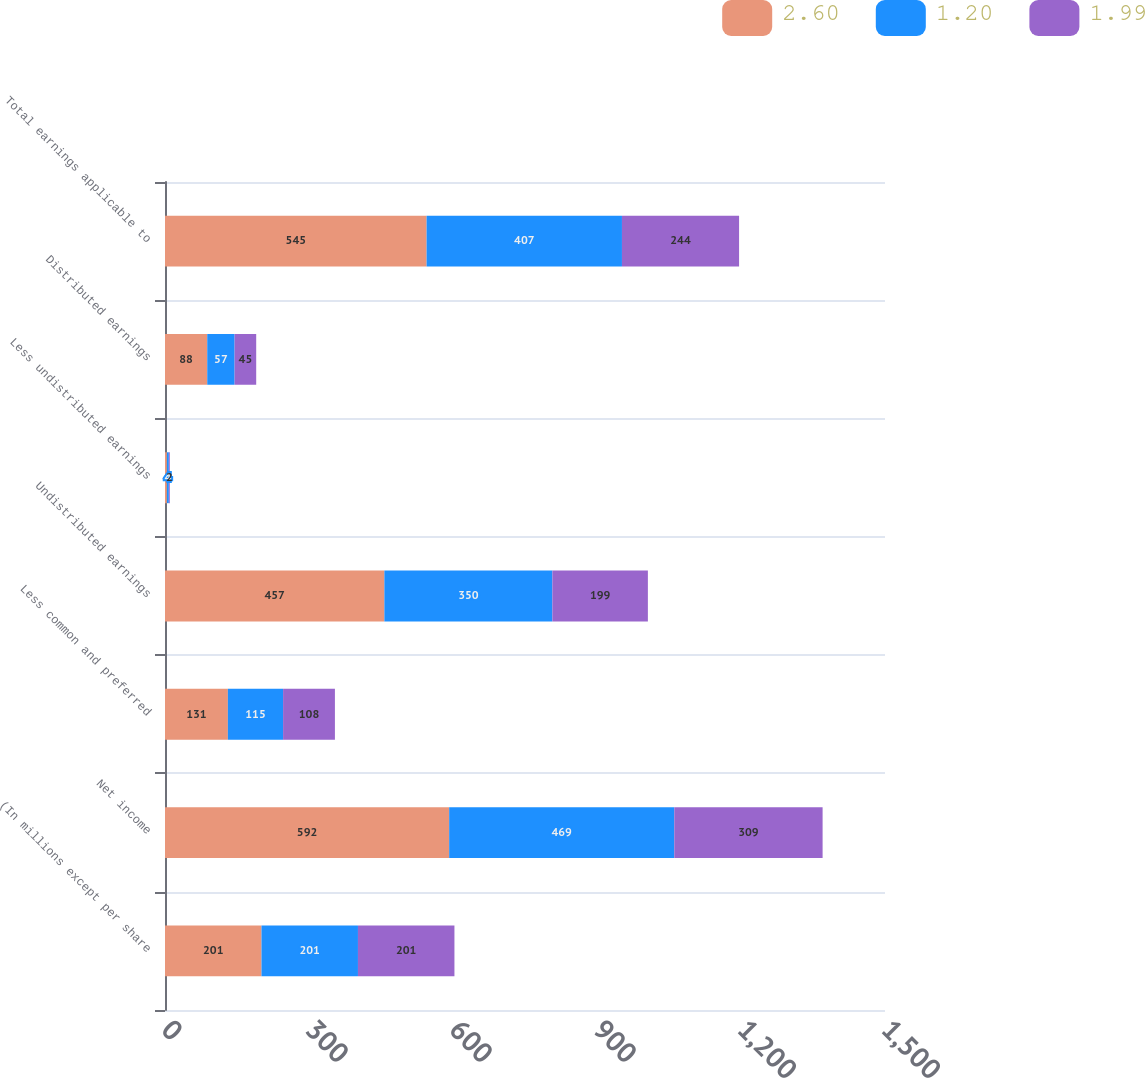Convert chart. <chart><loc_0><loc_0><loc_500><loc_500><stacked_bar_chart><ecel><fcel>(In millions except per share<fcel>Net income<fcel>Less common and preferred<fcel>Undistributed earnings<fcel>Less undistributed earnings<fcel>Distributed earnings<fcel>Total earnings applicable to<nl><fcel>2.6<fcel>201<fcel>592<fcel>131<fcel>457<fcel>4<fcel>88<fcel>545<nl><fcel>1.2<fcel>201<fcel>469<fcel>115<fcel>350<fcel>4<fcel>57<fcel>407<nl><fcel>1.99<fcel>201<fcel>309<fcel>108<fcel>199<fcel>2<fcel>45<fcel>244<nl></chart> 